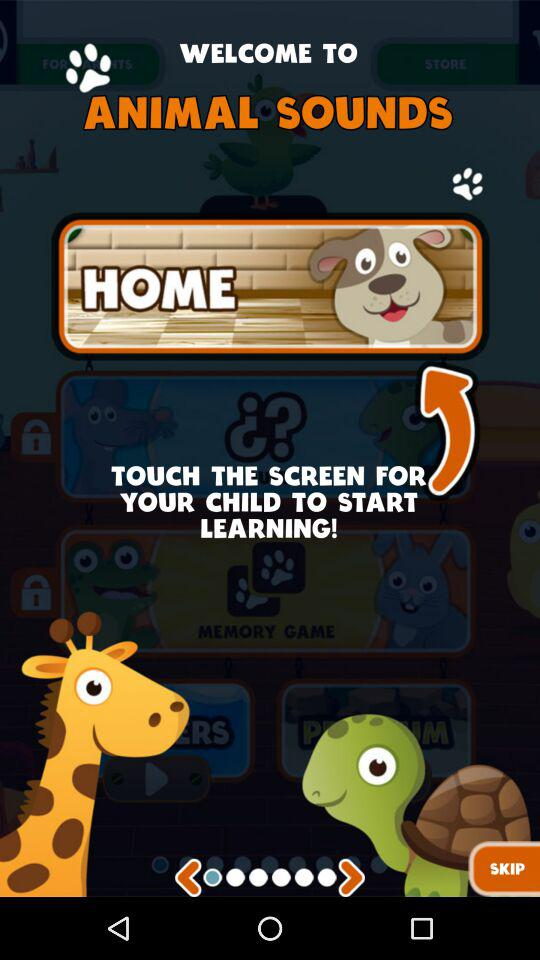What is the application name? The application name is "ANIMAL SOUNDS". 